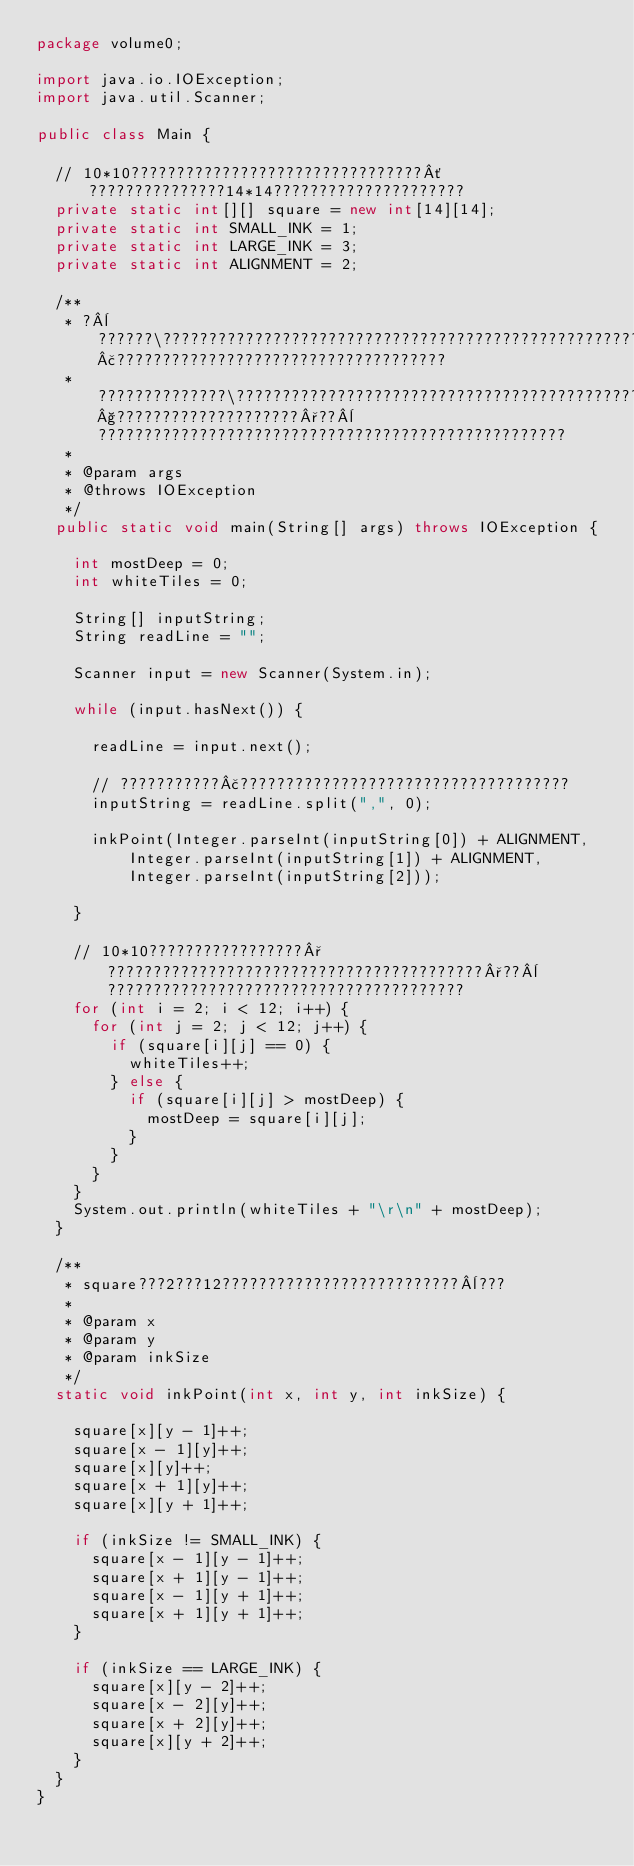<code> <loc_0><loc_0><loc_500><loc_500><_Java_>package volume0;

import java.io.IOException;
import java.util.Scanner;

public class Main {

	// 10*10????????????????????????????????´???????????????14*14?????????????????????
	private static int[][] square = new int[14][14];
	private static int SMALL_INK = 1;
	private static int LARGE_INK = 3;
	private static int ALIGNMENT = 2;

	/**
	 * ?¨??????\??????????????????????????????????????????????????????????????£????????????????????????????????????
	 * ??????????????\??????????????????????????????????????????????????§????????????????????°??¨???????????????????????????????????????????????????
	 *
	 * @param args
	 * @throws IOException
	 */
	public static void main(String[] args) throws IOException {

		int mostDeep = 0;
		int whiteTiles = 0;

		String[] inputString;
		String readLine = "";

		Scanner input = new Scanner(System.in);

		while (input.hasNext()) {

			readLine = input.next();

			// ???????????£????????????????????????????????????
			inputString = readLine.split(",", 0);

			inkPoint(Integer.parseInt(inputString[0]) + ALIGNMENT,
					Integer.parseInt(inputString[1]) + ALIGNMENT,
					Integer.parseInt(inputString[2]));

		}

		// 10*10?????????????????°?????????????????????????????????????????°??¨???????????????????????????????????????
		for (int i = 2; i < 12; i++) {
			for (int j = 2; j < 12; j++) {
				if (square[i][j] == 0) {
					whiteTiles++;
				} else {
					if (square[i][j] > mostDeep) {
						mostDeep = square[i][j];
					}
				}
			}
		}
		System.out.println(whiteTiles + "\r\n" + mostDeep);
	}

	/**
	 * square???2???12??????????????????????????¨???
	 *
	 * @param x
	 * @param y
	 * @param inkSize
	 */
	static void inkPoint(int x, int y, int inkSize) {

		square[x][y - 1]++;
		square[x - 1][y]++;
		square[x][y]++;
		square[x + 1][y]++;
		square[x][y + 1]++;

		if (inkSize != SMALL_INK) {
			square[x - 1][y - 1]++;
			square[x + 1][y - 1]++;
			square[x - 1][y + 1]++;
			square[x + 1][y + 1]++;
		}

		if (inkSize == LARGE_INK) {
			square[x][y - 2]++;
			square[x - 2][y]++;
			square[x + 2][y]++;
			square[x][y + 2]++;
		}
	}
}</code> 